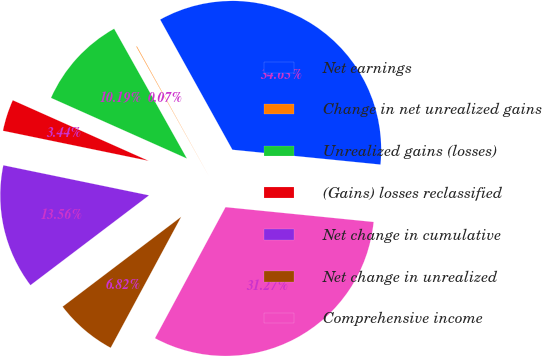Convert chart. <chart><loc_0><loc_0><loc_500><loc_500><pie_chart><fcel>Net earnings<fcel>Change in net unrealized gains<fcel>Unrealized gains (losses)<fcel>(Gains) losses reclassified<fcel>Net change in cumulative<fcel>Net change in unrealized<fcel>Comprehensive income<nl><fcel>34.65%<fcel>0.07%<fcel>10.19%<fcel>3.44%<fcel>13.56%<fcel>6.82%<fcel>31.27%<nl></chart> 